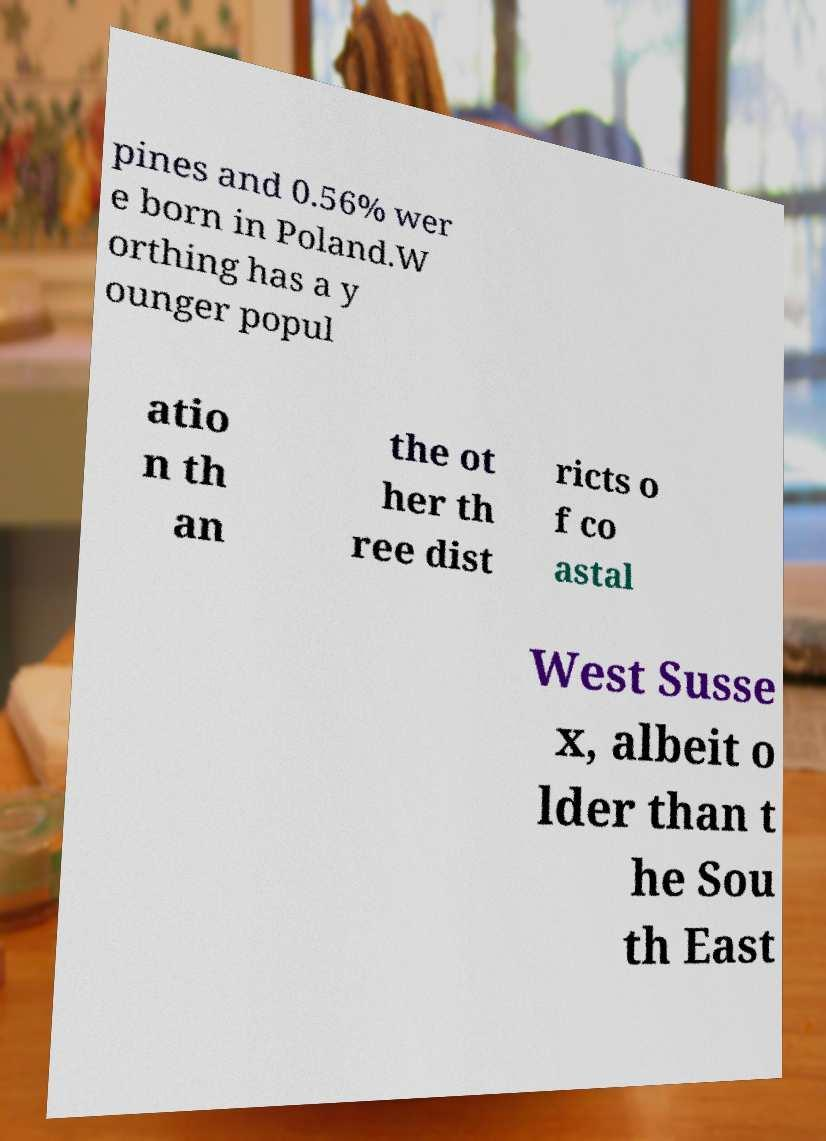There's text embedded in this image that I need extracted. Can you transcribe it verbatim? pines and 0.56% wer e born in Poland.W orthing has a y ounger popul atio n th an the ot her th ree dist ricts o f co astal West Susse x, albeit o lder than t he Sou th East 